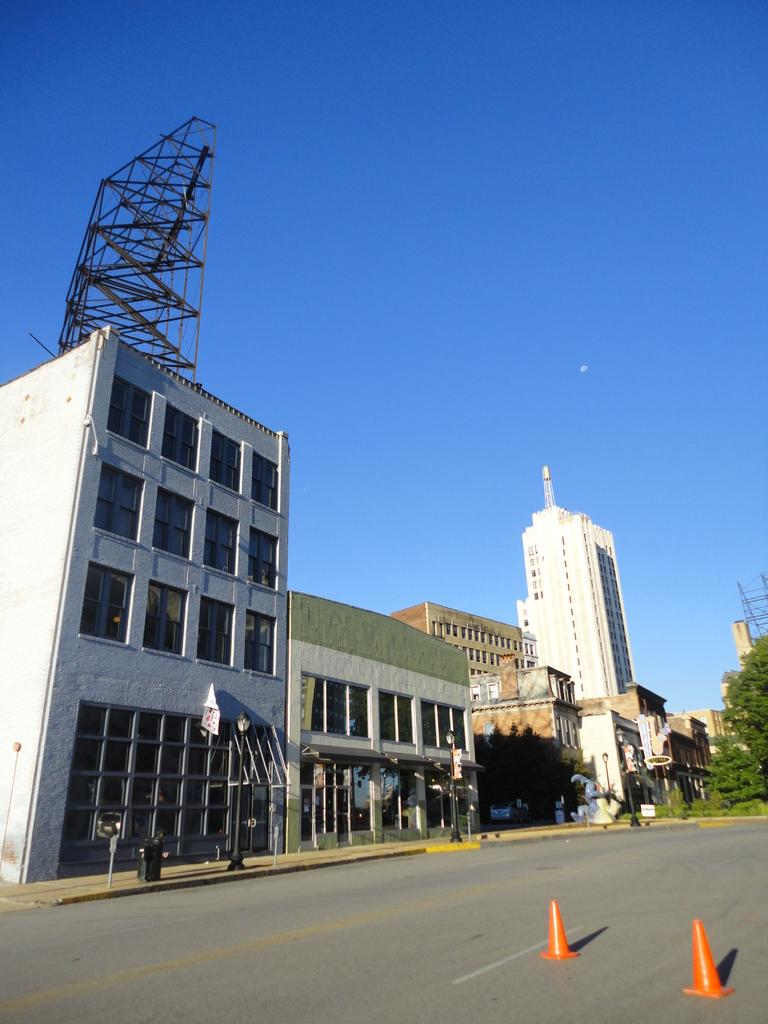What type of structures can be seen in the image? There are buildings in the image. What architectural features can be observed on the buildings? There are windows visible on the buildings. What type of street furniture is present in the image? There are light poles and traffic cones in the image. What type of waste disposal unit is present in the image? There is a dustbin in the image. What type of vegetation can be seen in the image? There are plants and trees in the image. What type of advertising is present in the image? There is a hoarding in the image. What part of the natural environment is visible in the image? The sky is visible in the image. What type of apple can be seen in the image? There is no apple present in the image. What type of drink is being consumed by the person in the image? There is no person or drink present in the image. 